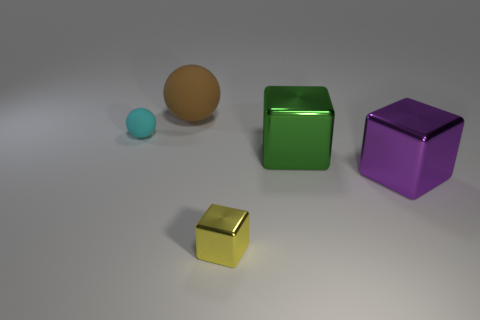There is another large rubber thing that is the same shape as the cyan matte thing; what color is it?
Make the answer very short. Brown. There is a rubber ball in front of the large brown object; does it have the same color as the large rubber ball?
Keep it short and to the point. No. What number of purple metal cubes are there?
Provide a succinct answer. 1. Are the tiny object that is in front of the small cyan rubber ball and the big brown sphere made of the same material?
Your answer should be very brief. No. Is there anything else that has the same material as the green cube?
Your answer should be very brief. Yes. There is a matte sphere in front of the rubber thing behind the small matte sphere; how many cyan rubber spheres are behind it?
Your response must be concise. 0. How big is the cyan sphere?
Provide a succinct answer. Small. Do the tiny metallic cube and the small rubber sphere have the same color?
Give a very brief answer. No. There is a matte sphere behind the cyan matte object; what size is it?
Give a very brief answer. Large. Do the object that is left of the big rubber ball and the matte sphere right of the cyan ball have the same color?
Your response must be concise. No. 